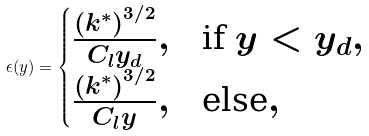Convert formula to latex. <formula><loc_0><loc_0><loc_500><loc_500>\epsilon ( y ) = \begin{cases} \frac { \left ( k ^ { * } \right ) ^ { 3 / 2 } } { C _ { l } y _ { d } } , & \text {if $y < y_{d},$} \\ \frac { \left ( k ^ { * } \right ) ^ { 3 / 2 } } { C _ { l } y } , & \text {else} , \end{cases}</formula> 